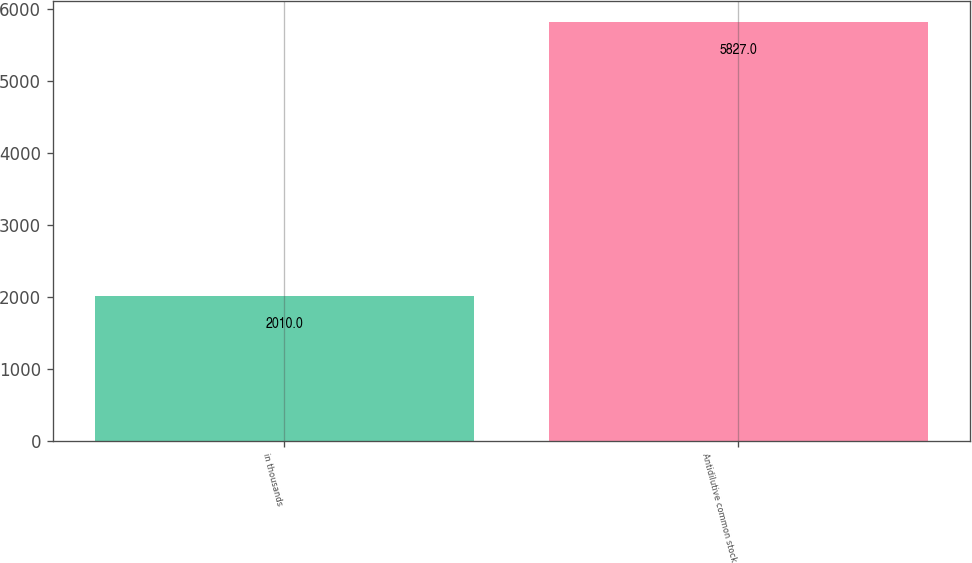Convert chart to OTSL. <chart><loc_0><loc_0><loc_500><loc_500><bar_chart><fcel>in thousands<fcel>Antidilutive common stock<nl><fcel>2010<fcel>5827<nl></chart> 